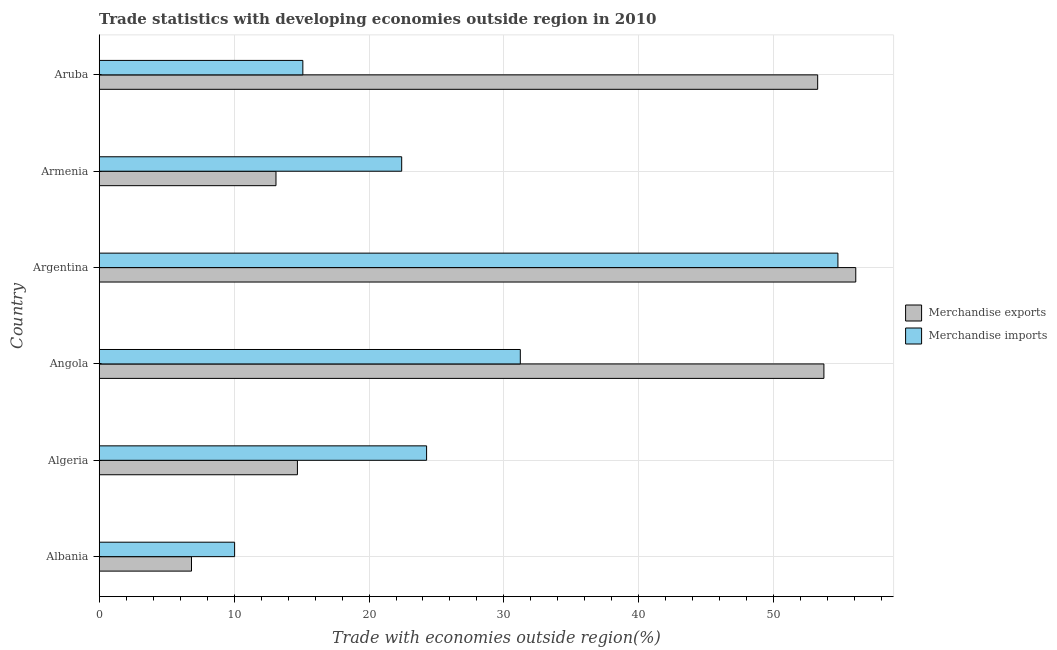How many different coloured bars are there?
Your answer should be compact. 2. How many groups of bars are there?
Your answer should be compact. 6. Are the number of bars per tick equal to the number of legend labels?
Provide a short and direct response. Yes. Are the number of bars on each tick of the Y-axis equal?
Offer a terse response. Yes. How many bars are there on the 4th tick from the top?
Your answer should be compact. 2. What is the label of the 4th group of bars from the top?
Your answer should be compact. Angola. In how many cases, is the number of bars for a given country not equal to the number of legend labels?
Provide a short and direct response. 0. What is the merchandise exports in Argentina?
Offer a very short reply. 56.08. Across all countries, what is the maximum merchandise imports?
Your answer should be very brief. 54.76. Across all countries, what is the minimum merchandise imports?
Offer a very short reply. 10.04. In which country was the merchandise imports maximum?
Give a very brief answer. Argentina. In which country was the merchandise exports minimum?
Your answer should be very brief. Albania. What is the total merchandise exports in the graph?
Offer a very short reply. 197.7. What is the difference between the merchandise imports in Algeria and that in Argentina?
Make the answer very short. -30.49. What is the difference between the merchandise exports in Albania and the merchandise imports in Algeria?
Provide a succinct answer. -17.43. What is the average merchandise imports per country?
Your response must be concise. 26.3. What is the difference between the merchandise imports and merchandise exports in Armenia?
Offer a terse response. 9.32. In how many countries, is the merchandise imports greater than 2 %?
Provide a succinct answer. 6. What is the ratio of the merchandise exports in Argentina to that in Aruba?
Keep it short and to the point. 1.05. Is the difference between the merchandise exports in Algeria and Armenia greater than the difference between the merchandise imports in Algeria and Armenia?
Offer a terse response. No. What is the difference between the highest and the second highest merchandise imports?
Offer a terse response. 23.54. What is the difference between the highest and the lowest merchandise exports?
Offer a terse response. 49.24. In how many countries, is the merchandise exports greater than the average merchandise exports taken over all countries?
Offer a terse response. 3. What does the 1st bar from the top in Argentina represents?
Offer a very short reply. Merchandise imports. What does the 2nd bar from the bottom in Algeria represents?
Provide a succinct answer. Merchandise imports. How many bars are there?
Your response must be concise. 12. Are all the bars in the graph horizontal?
Make the answer very short. Yes. What is the difference between two consecutive major ticks on the X-axis?
Give a very brief answer. 10. Are the values on the major ticks of X-axis written in scientific E-notation?
Your response must be concise. No. Does the graph contain any zero values?
Give a very brief answer. No. Does the graph contain grids?
Offer a very short reply. Yes. How are the legend labels stacked?
Make the answer very short. Vertical. What is the title of the graph?
Ensure brevity in your answer.  Trade statistics with developing economies outside region in 2010. Does "Borrowers" appear as one of the legend labels in the graph?
Offer a very short reply. No. What is the label or title of the X-axis?
Offer a very short reply. Trade with economies outside region(%). What is the Trade with economies outside region(%) in Merchandise exports in Albania?
Provide a short and direct response. 6.84. What is the Trade with economies outside region(%) in Merchandise imports in Albania?
Your answer should be compact. 10.04. What is the Trade with economies outside region(%) in Merchandise exports in Algeria?
Make the answer very short. 14.69. What is the Trade with economies outside region(%) in Merchandise imports in Algeria?
Offer a very short reply. 24.27. What is the Trade with economies outside region(%) in Merchandise exports in Angola?
Make the answer very short. 53.72. What is the Trade with economies outside region(%) of Merchandise imports in Angola?
Offer a terse response. 31.22. What is the Trade with economies outside region(%) in Merchandise exports in Argentina?
Keep it short and to the point. 56.08. What is the Trade with economies outside region(%) of Merchandise imports in Argentina?
Offer a terse response. 54.76. What is the Trade with economies outside region(%) in Merchandise exports in Armenia?
Keep it short and to the point. 13.1. What is the Trade with economies outside region(%) of Merchandise imports in Armenia?
Your answer should be compact. 22.42. What is the Trade with economies outside region(%) in Merchandise exports in Aruba?
Your answer should be very brief. 53.26. What is the Trade with economies outside region(%) of Merchandise imports in Aruba?
Your answer should be compact. 15.1. Across all countries, what is the maximum Trade with economies outside region(%) in Merchandise exports?
Offer a very short reply. 56.08. Across all countries, what is the maximum Trade with economies outside region(%) in Merchandise imports?
Your response must be concise. 54.76. Across all countries, what is the minimum Trade with economies outside region(%) of Merchandise exports?
Keep it short and to the point. 6.84. Across all countries, what is the minimum Trade with economies outside region(%) of Merchandise imports?
Give a very brief answer. 10.04. What is the total Trade with economies outside region(%) in Merchandise exports in the graph?
Make the answer very short. 197.7. What is the total Trade with economies outside region(%) in Merchandise imports in the graph?
Your answer should be very brief. 157.8. What is the difference between the Trade with economies outside region(%) in Merchandise exports in Albania and that in Algeria?
Your answer should be compact. -7.85. What is the difference between the Trade with economies outside region(%) of Merchandise imports in Albania and that in Algeria?
Provide a succinct answer. -14.23. What is the difference between the Trade with economies outside region(%) of Merchandise exports in Albania and that in Angola?
Provide a succinct answer. -46.88. What is the difference between the Trade with economies outside region(%) of Merchandise imports in Albania and that in Angola?
Provide a succinct answer. -21.18. What is the difference between the Trade with economies outside region(%) of Merchandise exports in Albania and that in Argentina?
Ensure brevity in your answer.  -49.24. What is the difference between the Trade with economies outside region(%) in Merchandise imports in Albania and that in Argentina?
Make the answer very short. -44.72. What is the difference between the Trade with economies outside region(%) of Merchandise exports in Albania and that in Armenia?
Provide a short and direct response. -6.26. What is the difference between the Trade with economies outside region(%) of Merchandise imports in Albania and that in Armenia?
Give a very brief answer. -12.39. What is the difference between the Trade with economies outside region(%) of Merchandise exports in Albania and that in Aruba?
Your answer should be compact. -46.42. What is the difference between the Trade with economies outside region(%) in Merchandise imports in Albania and that in Aruba?
Your answer should be compact. -5.06. What is the difference between the Trade with economies outside region(%) of Merchandise exports in Algeria and that in Angola?
Provide a succinct answer. -39.03. What is the difference between the Trade with economies outside region(%) in Merchandise imports in Algeria and that in Angola?
Make the answer very short. -6.95. What is the difference between the Trade with economies outside region(%) of Merchandise exports in Algeria and that in Argentina?
Your answer should be compact. -41.39. What is the difference between the Trade with economies outside region(%) of Merchandise imports in Algeria and that in Argentina?
Offer a very short reply. -30.49. What is the difference between the Trade with economies outside region(%) in Merchandise exports in Algeria and that in Armenia?
Your answer should be very brief. 1.59. What is the difference between the Trade with economies outside region(%) in Merchandise imports in Algeria and that in Armenia?
Offer a terse response. 1.85. What is the difference between the Trade with economies outside region(%) of Merchandise exports in Algeria and that in Aruba?
Provide a succinct answer. -38.57. What is the difference between the Trade with economies outside region(%) of Merchandise imports in Algeria and that in Aruba?
Keep it short and to the point. 9.17. What is the difference between the Trade with economies outside region(%) of Merchandise exports in Angola and that in Argentina?
Keep it short and to the point. -2.36. What is the difference between the Trade with economies outside region(%) of Merchandise imports in Angola and that in Argentina?
Your answer should be compact. -23.54. What is the difference between the Trade with economies outside region(%) of Merchandise exports in Angola and that in Armenia?
Give a very brief answer. 40.62. What is the difference between the Trade with economies outside region(%) in Merchandise imports in Angola and that in Armenia?
Your answer should be very brief. 8.79. What is the difference between the Trade with economies outside region(%) of Merchandise exports in Angola and that in Aruba?
Offer a very short reply. 0.46. What is the difference between the Trade with economies outside region(%) of Merchandise imports in Angola and that in Aruba?
Give a very brief answer. 16.12. What is the difference between the Trade with economies outside region(%) in Merchandise exports in Argentina and that in Armenia?
Your answer should be very brief. 42.98. What is the difference between the Trade with economies outside region(%) of Merchandise imports in Argentina and that in Armenia?
Keep it short and to the point. 32.34. What is the difference between the Trade with economies outside region(%) in Merchandise exports in Argentina and that in Aruba?
Your response must be concise. 2.82. What is the difference between the Trade with economies outside region(%) of Merchandise imports in Argentina and that in Aruba?
Offer a terse response. 39.66. What is the difference between the Trade with economies outside region(%) in Merchandise exports in Armenia and that in Aruba?
Give a very brief answer. -40.15. What is the difference between the Trade with economies outside region(%) in Merchandise imports in Armenia and that in Aruba?
Give a very brief answer. 7.33. What is the difference between the Trade with economies outside region(%) in Merchandise exports in Albania and the Trade with economies outside region(%) in Merchandise imports in Algeria?
Give a very brief answer. -17.43. What is the difference between the Trade with economies outside region(%) of Merchandise exports in Albania and the Trade with economies outside region(%) of Merchandise imports in Angola?
Ensure brevity in your answer.  -24.38. What is the difference between the Trade with economies outside region(%) of Merchandise exports in Albania and the Trade with economies outside region(%) of Merchandise imports in Argentina?
Offer a terse response. -47.92. What is the difference between the Trade with economies outside region(%) in Merchandise exports in Albania and the Trade with economies outside region(%) in Merchandise imports in Armenia?
Provide a short and direct response. -15.58. What is the difference between the Trade with economies outside region(%) in Merchandise exports in Albania and the Trade with economies outside region(%) in Merchandise imports in Aruba?
Your response must be concise. -8.25. What is the difference between the Trade with economies outside region(%) in Merchandise exports in Algeria and the Trade with economies outside region(%) in Merchandise imports in Angola?
Your answer should be compact. -16.52. What is the difference between the Trade with economies outside region(%) in Merchandise exports in Algeria and the Trade with economies outside region(%) in Merchandise imports in Argentina?
Give a very brief answer. -40.07. What is the difference between the Trade with economies outside region(%) in Merchandise exports in Algeria and the Trade with economies outside region(%) in Merchandise imports in Armenia?
Offer a terse response. -7.73. What is the difference between the Trade with economies outside region(%) in Merchandise exports in Algeria and the Trade with economies outside region(%) in Merchandise imports in Aruba?
Your response must be concise. -0.4. What is the difference between the Trade with economies outside region(%) in Merchandise exports in Angola and the Trade with economies outside region(%) in Merchandise imports in Argentina?
Ensure brevity in your answer.  -1.04. What is the difference between the Trade with economies outside region(%) of Merchandise exports in Angola and the Trade with economies outside region(%) of Merchandise imports in Armenia?
Your answer should be compact. 31.3. What is the difference between the Trade with economies outside region(%) in Merchandise exports in Angola and the Trade with economies outside region(%) in Merchandise imports in Aruba?
Provide a short and direct response. 38.63. What is the difference between the Trade with economies outside region(%) of Merchandise exports in Argentina and the Trade with economies outside region(%) of Merchandise imports in Armenia?
Your answer should be compact. 33.66. What is the difference between the Trade with economies outside region(%) in Merchandise exports in Argentina and the Trade with economies outside region(%) in Merchandise imports in Aruba?
Provide a short and direct response. 40.99. What is the difference between the Trade with economies outside region(%) in Merchandise exports in Armenia and the Trade with economies outside region(%) in Merchandise imports in Aruba?
Your response must be concise. -1.99. What is the average Trade with economies outside region(%) of Merchandise exports per country?
Give a very brief answer. 32.95. What is the average Trade with economies outside region(%) of Merchandise imports per country?
Your response must be concise. 26.3. What is the difference between the Trade with economies outside region(%) of Merchandise exports and Trade with economies outside region(%) of Merchandise imports in Albania?
Your answer should be compact. -3.2. What is the difference between the Trade with economies outside region(%) in Merchandise exports and Trade with economies outside region(%) in Merchandise imports in Algeria?
Provide a short and direct response. -9.58. What is the difference between the Trade with economies outside region(%) of Merchandise exports and Trade with economies outside region(%) of Merchandise imports in Angola?
Keep it short and to the point. 22.51. What is the difference between the Trade with economies outside region(%) of Merchandise exports and Trade with economies outside region(%) of Merchandise imports in Argentina?
Keep it short and to the point. 1.32. What is the difference between the Trade with economies outside region(%) of Merchandise exports and Trade with economies outside region(%) of Merchandise imports in Armenia?
Your answer should be compact. -9.32. What is the difference between the Trade with economies outside region(%) of Merchandise exports and Trade with economies outside region(%) of Merchandise imports in Aruba?
Your answer should be compact. 38.16. What is the ratio of the Trade with economies outside region(%) of Merchandise exports in Albania to that in Algeria?
Keep it short and to the point. 0.47. What is the ratio of the Trade with economies outside region(%) in Merchandise imports in Albania to that in Algeria?
Your answer should be compact. 0.41. What is the ratio of the Trade with economies outside region(%) in Merchandise exports in Albania to that in Angola?
Ensure brevity in your answer.  0.13. What is the ratio of the Trade with economies outside region(%) of Merchandise imports in Albania to that in Angola?
Your answer should be very brief. 0.32. What is the ratio of the Trade with economies outside region(%) in Merchandise exports in Albania to that in Argentina?
Your answer should be very brief. 0.12. What is the ratio of the Trade with economies outside region(%) of Merchandise imports in Albania to that in Argentina?
Ensure brevity in your answer.  0.18. What is the ratio of the Trade with economies outside region(%) in Merchandise exports in Albania to that in Armenia?
Give a very brief answer. 0.52. What is the ratio of the Trade with economies outside region(%) of Merchandise imports in Albania to that in Armenia?
Offer a terse response. 0.45. What is the ratio of the Trade with economies outside region(%) of Merchandise exports in Albania to that in Aruba?
Make the answer very short. 0.13. What is the ratio of the Trade with economies outside region(%) of Merchandise imports in Albania to that in Aruba?
Provide a short and direct response. 0.66. What is the ratio of the Trade with economies outside region(%) in Merchandise exports in Algeria to that in Angola?
Offer a very short reply. 0.27. What is the ratio of the Trade with economies outside region(%) in Merchandise imports in Algeria to that in Angola?
Make the answer very short. 0.78. What is the ratio of the Trade with economies outside region(%) in Merchandise exports in Algeria to that in Argentina?
Offer a terse response. 0.26. What is the ratio of the Trade with economies outside region(%) of Merchandise imports in Algeria to that in Argentina?
Make the answer very short. 0.44. What is the ratio of the Trade with economies outside region(%) in Merchandise exports in Algeria to that in Armenia?
Provide a succinct answer. 1.12. What is the ratio of the Trade with economies outside region(%) in Merchandise imports in Algeria to that in Armenia?
Offer a very short reply. 1.08. What is the ratio of the Trade with economies outside region(%) in Merchandise exports in Algeria to that in Aruba?
Provide a short and direct response. 0.28. What is the ratio of the Trade with economies outside region(%) of Merchandise imports in Algeria to that in Aruba?
Ensure brevity in your answer.  1.61. What is the ratio of the Trade with economies outside region(%) in Merchandise exports in Angola to that in Argentina?
Provide a short and direct response. 0.96. What is the ratio of the Trade with economies outside region(%) of Merchandise imports in Angola to that in Argentina?
Give a very brief answer. 0.57. What is the ratio of the Trade with economies outside region(%) of Merchandise exports in Angola to that in Armenia?
Provide a succinct answer. 4.1. What is the ratio of the Trade with economies outside region(%) in Merchandise imports in Angola to that in Armenia?
Your answer should be very brief. 1.39. What is the ratio of the Trade with economies outside region(%) in Merchandise exports in Angola to that in Aruba?
Offer a terse response. 1.01. What is the ratio of the Trade with economies outside region(%) of Merchandise imports in Angola to that in Aruba?
Provide a short and direct response. 2.07. What is the ratio of the Trade with economies outside region(%) of Merchandise exports in Argentina to that in Armenia?
Your answer should be very brief. 4.28. What is the ratio of the Trade with economies outside region(%) in Merchandise imports in Argentina to that in Armenia?
Your response must be concise. 2.44. What is the ratio of the Trade with economies outside region(%) in Merchandise exports in Argentina to that in Aruba?
Offer a very short reply. 1.05. What is the ratio of the Trade with economies outside region(%) in Merchandise imports in Argentina to that in Aruba?
Offer a terse response. 3.63. What is the ratio of the Trade with economies outside region(%) in Merchandise exports in Armenia to that in Aruba?
Ensure brevity in your answer.  0.25. What is the ratio of the Trade with economies outside region(%) in Merchandise imports in Armenia to that in Aruba?
Your answer should be compact. 1.49. What is the difference between the highest and the second highest Trade with economies outside region(%) in Merchandise exports?
Offer a very short reply. 2.36. What is the difference between the highest and the second highest Trade with economies outside region(%) in Merchandise imports?
Keep it short and to the point. 23.54. What is the difference between the highest and the lowest Trade with economies outside region(%) of Merchandise exports?
Your response must be concise. 49.24. What is the difference between the highest and the lowest Trade with economies outside region(%) in Merchandise imports?
Give a very brief answer. 44.72. 